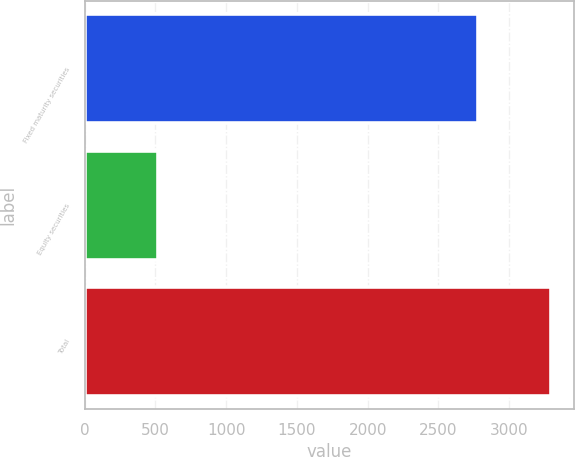Convert chart. <chart><loc_0><loc_0><loc_500><loc_500><bar_chart><fcel>Fixed maturity securities<fcel>Equity securities<fcel>Total<nl><fcel>2778<fcel>515<fcel>3293<nl></chart> 